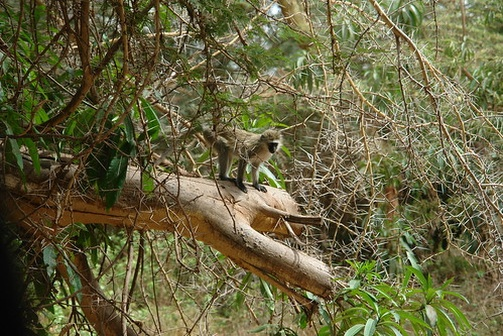What do you see happening in this image? The image captures a lively scene in a dense, vibrant forest. A small monkey is perched confidently on a thick, horizontal tree branch, which is surrounded by an intricate network of branches and lush green leaves. The monkey, seeming curious and alert, is facing the camera, giving the impression that it is aware of being observed. The natural lighting filtering through the foliage highlights the rich textures of the monkey’s fur and the bark of the tree. The background, a soft blur of additional trees and foliage, gently frames the scene, keeping the focus on the monkey. The composition creates a sense of harmony and exploration, evoking the untamed beauty of the forest environment. There's no text or other discernible objects in the image, allowing the viewer to immerse fully in this slice of wildlife. 